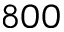Convert formula to latex. <formula><loc_0><loc_0><loc_500><loc_500>8 0 0</formula> 